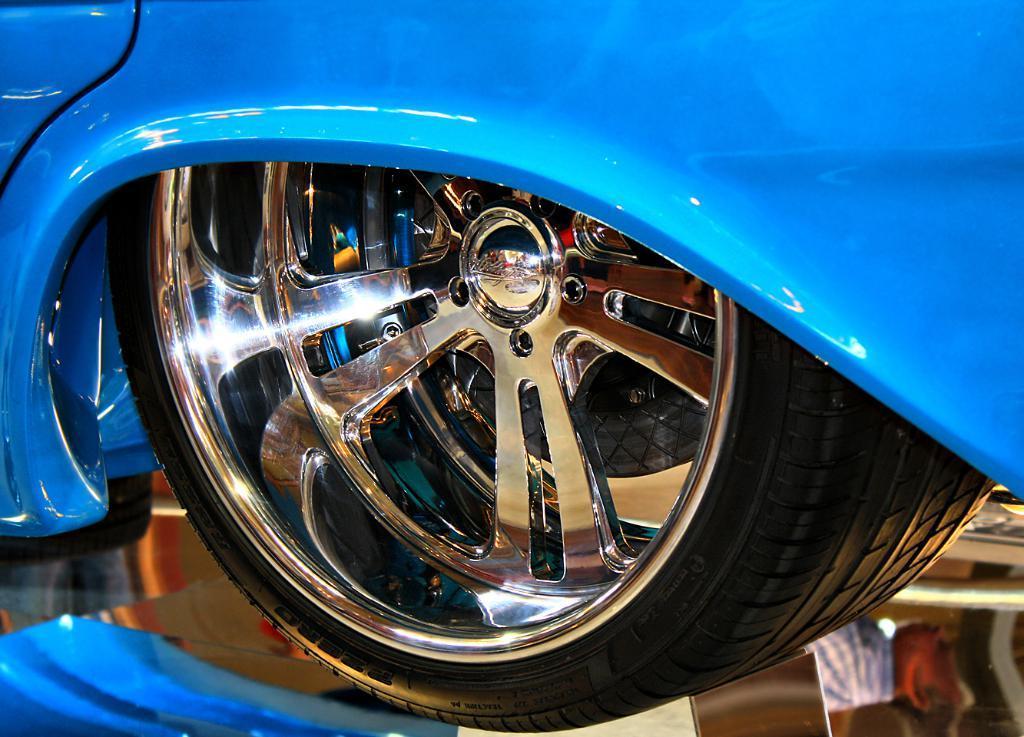Can you describe this image briefly? In this image we can see that there is a Tyre of a vehicle. At the bottom there is a glass. In the glass we can see the reflections of two persons. 